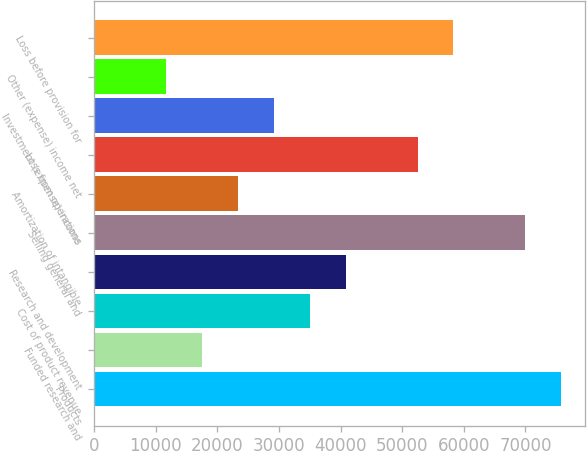Convert chart. <chart><loc_0><loc_0><loc_500><loc_500><bar_chart><fcel>Products<fcel>Funded research and<fcel>Cost of product revenue<fcel>Research and development<fcel>Selling general and<fcel>Amortization of intangible<fcel>Loss from operations<fcel>Investment (expense) income<fcel>Other (expense) income net<fcel>Loss before provision for<nl><fcel>75818.2<fcel>17497.5<fcel>34993.7<fcel>40825.8<fcel>69986.1<fcel>23329.5<fcel>52489.9<fcel>29161.6<fcel>11665.4<fcel>58322<nl></chart> 